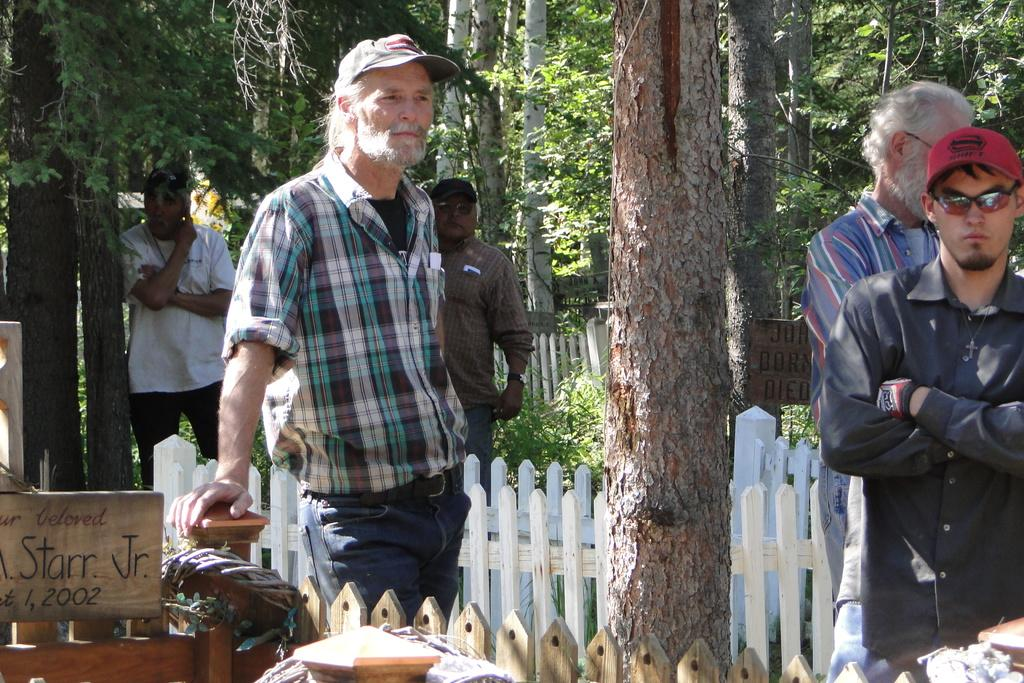What are the people in the image doing? The people in the image are standing on the ground. What type of natural elements can be seen in the image? There are trees in the image. What type of barrier is present in the image? There is a wooden fence in the image. What type of signage is present in the image? There are boards with text in the image. How many children are playing with the doll in the image? There is no doll or children present in the image. What type of company is represented by the boards with text in the image? The boards with text in the image do not represent a company; they are simply signage with text. 